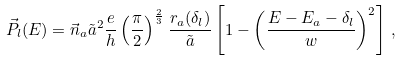Convert formula to latex. <formula><loc_0><loc_0><loc_500><loc_500>\vec { P } _ { l } ( E ) = \vec { n } _ { a } \tilde { a } ^ { 2 } \frac { e } { h } \left ( \frac { \pi } { 2 } \right ) ^ { \frac { 2 } { 3 } } \frac { r _ { a } ( \delta _ { l } ) } { \tilde { a } } \left [ 1 - \left ( \frac { E - E _ { a } - \delta _ { l } } { w } \right ) ^ { 2 } \right ] \, ,</formula> 